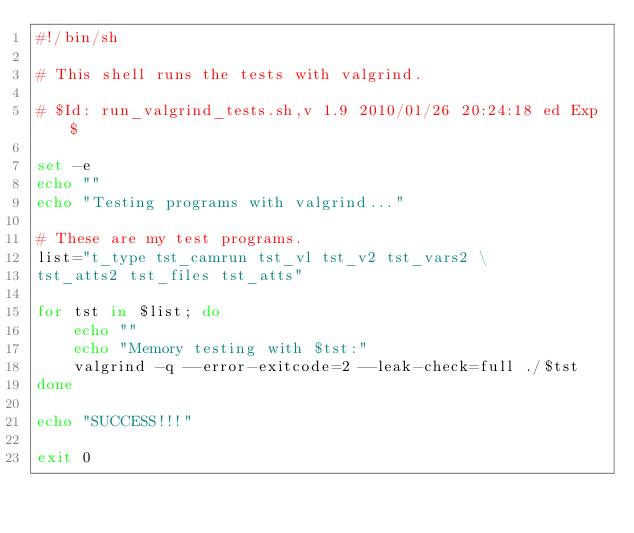<code> <loc_0><loc_0><loc_500><loc_500><_Bash_>#!/bin/sh

# This shell runs the tests with valgrind.

# $Id: run_valgrind_tests.sh,v 1.9 2010/01/26 20:24:18 ed Exp $

set -e
echo ""
echo "Testing programs with valgrind..."

# These are my test programs.
list="t_type tst_camrun tst_vl tst_v2 tst_vars2 \
tst_atts2 tst_files tst_atts"

for tst in $list; do
    echo ""
    echo "Memory testing with $tst:"
    valgrind -q --error-exitcode=2 --leak-check=full ./$tst
done

echo "SUCCESS!!!"

exit 0
</code> 